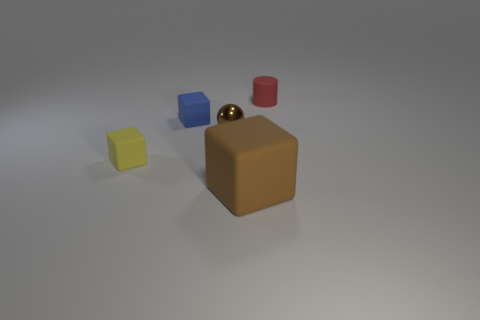How do the colors of the objects influence their appearance? The colors have a significant impact on the visual perception of these objects. The vibrant yellow and blue stand out against the more subdued brown and red, creating a palette that draws the eye from one object to another. The differences in colors can also affect the perception of depth and size, making some objects appear closer or larger than they might actually be. Do the colors have any symbolic meaning? While these objects could be interpreted purely as visual elements without inherent symbolism, colors often carry cultural or personal meanings. For example, yellow can represent energy and happiness, blue might evoke feelings of calmness and stability, red can signal passion or danger, and brown often represents the earth or reliability. Given the simplicity of the scene, any symbolic interpretation would be subjective and reliant on the viewer's personal associations. 